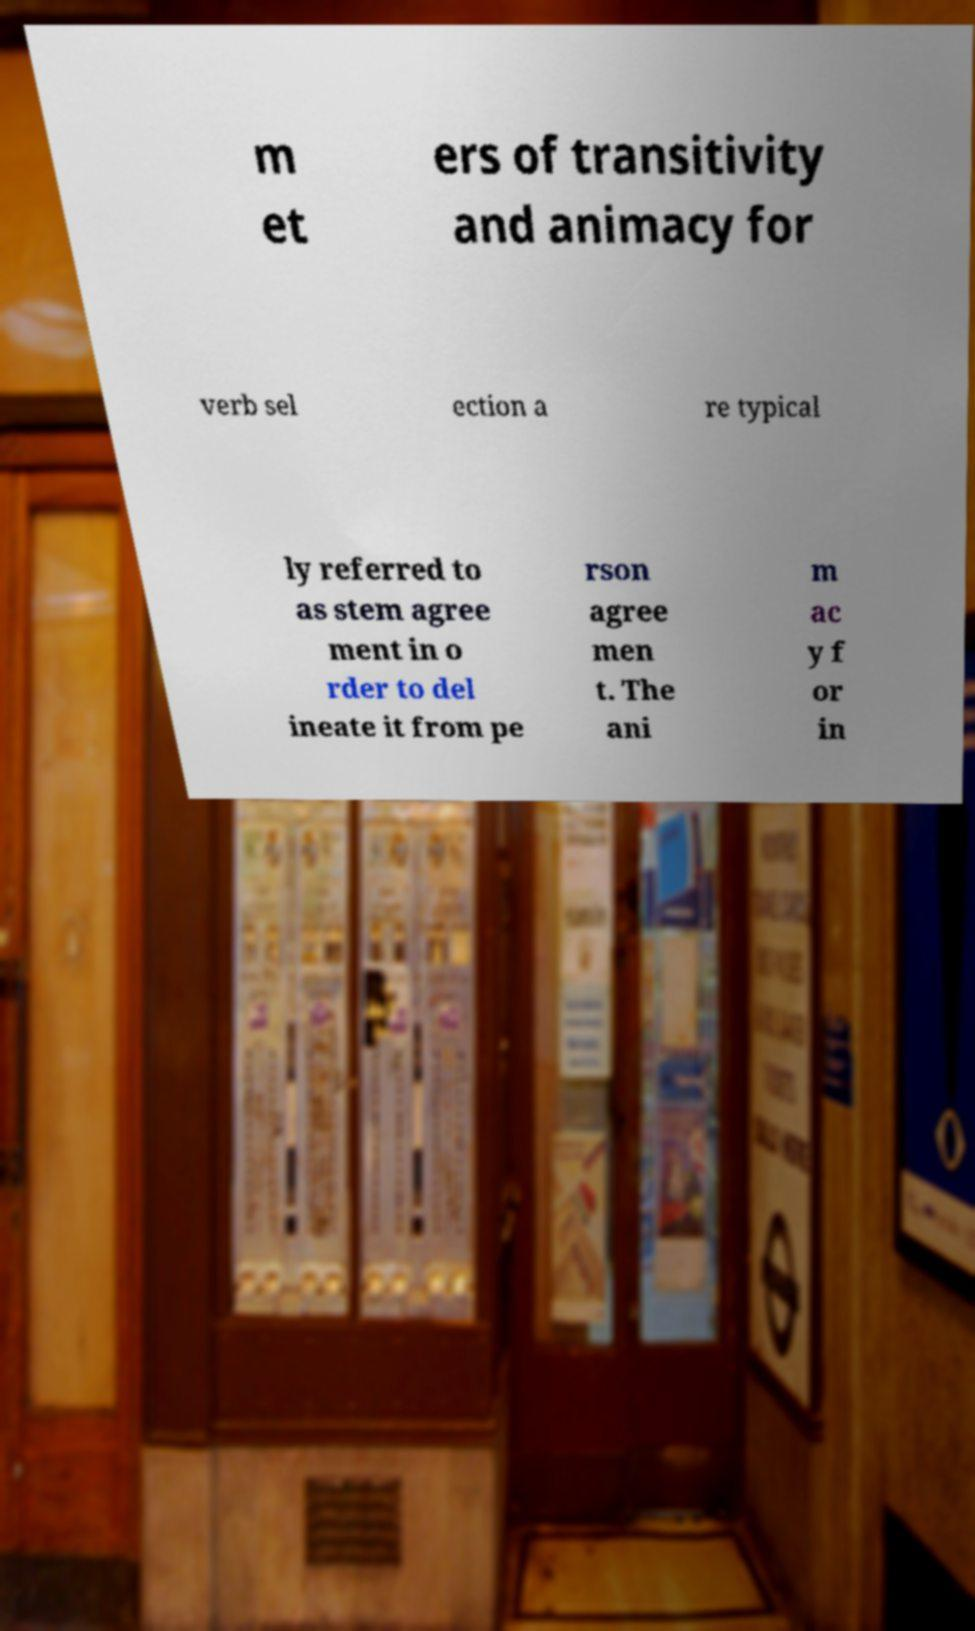Can you read and provide the text displayed in the image?This photo seems to have some interesting text. Can you extract and type it out for me? m et ers of transitivity and animacy for verb sel ection a re typical ly referred to as stem agree ment in o rder to del ineate it from pe rson agree men t. The ani m ac y f or in 